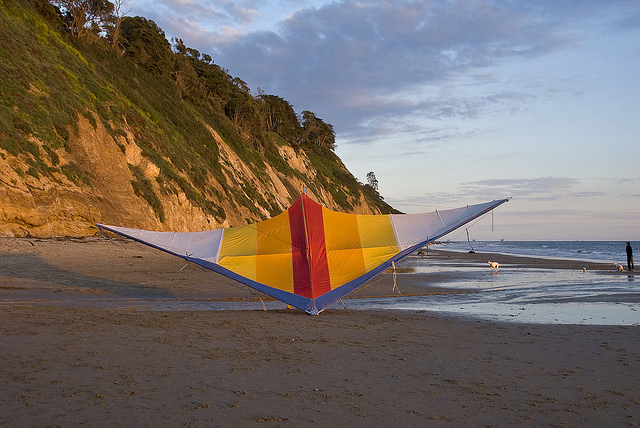Is the kite in the air or on the ground? The kite is resting on the ground, specifically on the sandy beach, rather than flying in the air. 